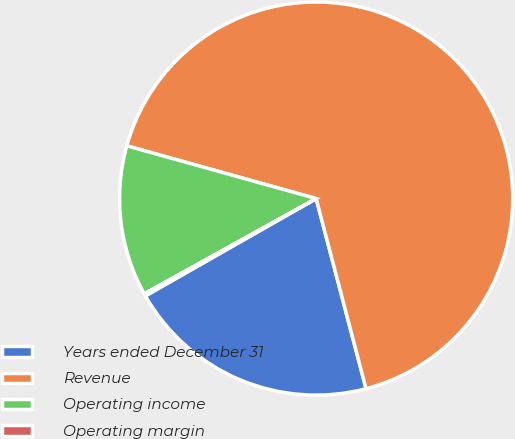Convert chart. <chart><loc_0><loc_0><loc_500><loc_500><pie_chart><fcel>Years ended December 31<fcel>Revenue<fcel>Operating income<fcel>Operating margin<nl><fcel>20.84%<fcel>66.59%<fcel>12.38%<fcel>0.19%<nl></chart> 